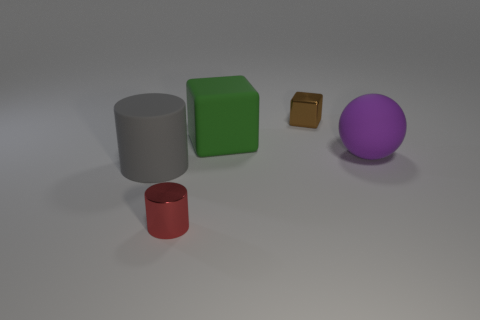Is the shape of the metallic object that is left of the green matte object the same as  the large green object?
Keep it short and to the point. No. Are there fewer small brown cubes in front of the big gray matte cylinder than brown things that are right of the large purple rubber object?
Give a very brief answer. No. What material is the big cylinder?
Offer a very short reply. Rubber. Does the large rubber ball have the same color as the cylinder that is right of the gray object?
Offer a very short reply. No. How many blocks are behind the small shiny cylinder?
Provide a short and direct response. 2. Are there fewer small brown metal objects that are on the left side of the brown cube than purple rubber objects?
Provide a short and direct response. Yes. What is the color of the rubber ball?
Ensure brevity in your answer.  Purple. Does the large object that is in front of the big purple object have the same color as the metal cylinder?
Offer a very short reply. No. What is the color of the big rubber object that is the same shape as the tiny brown shiny object?
Give a very brief answer. Green. How many big objects are either rubber objects or yellow shiny cubes?
Offer a terse response. 3. 